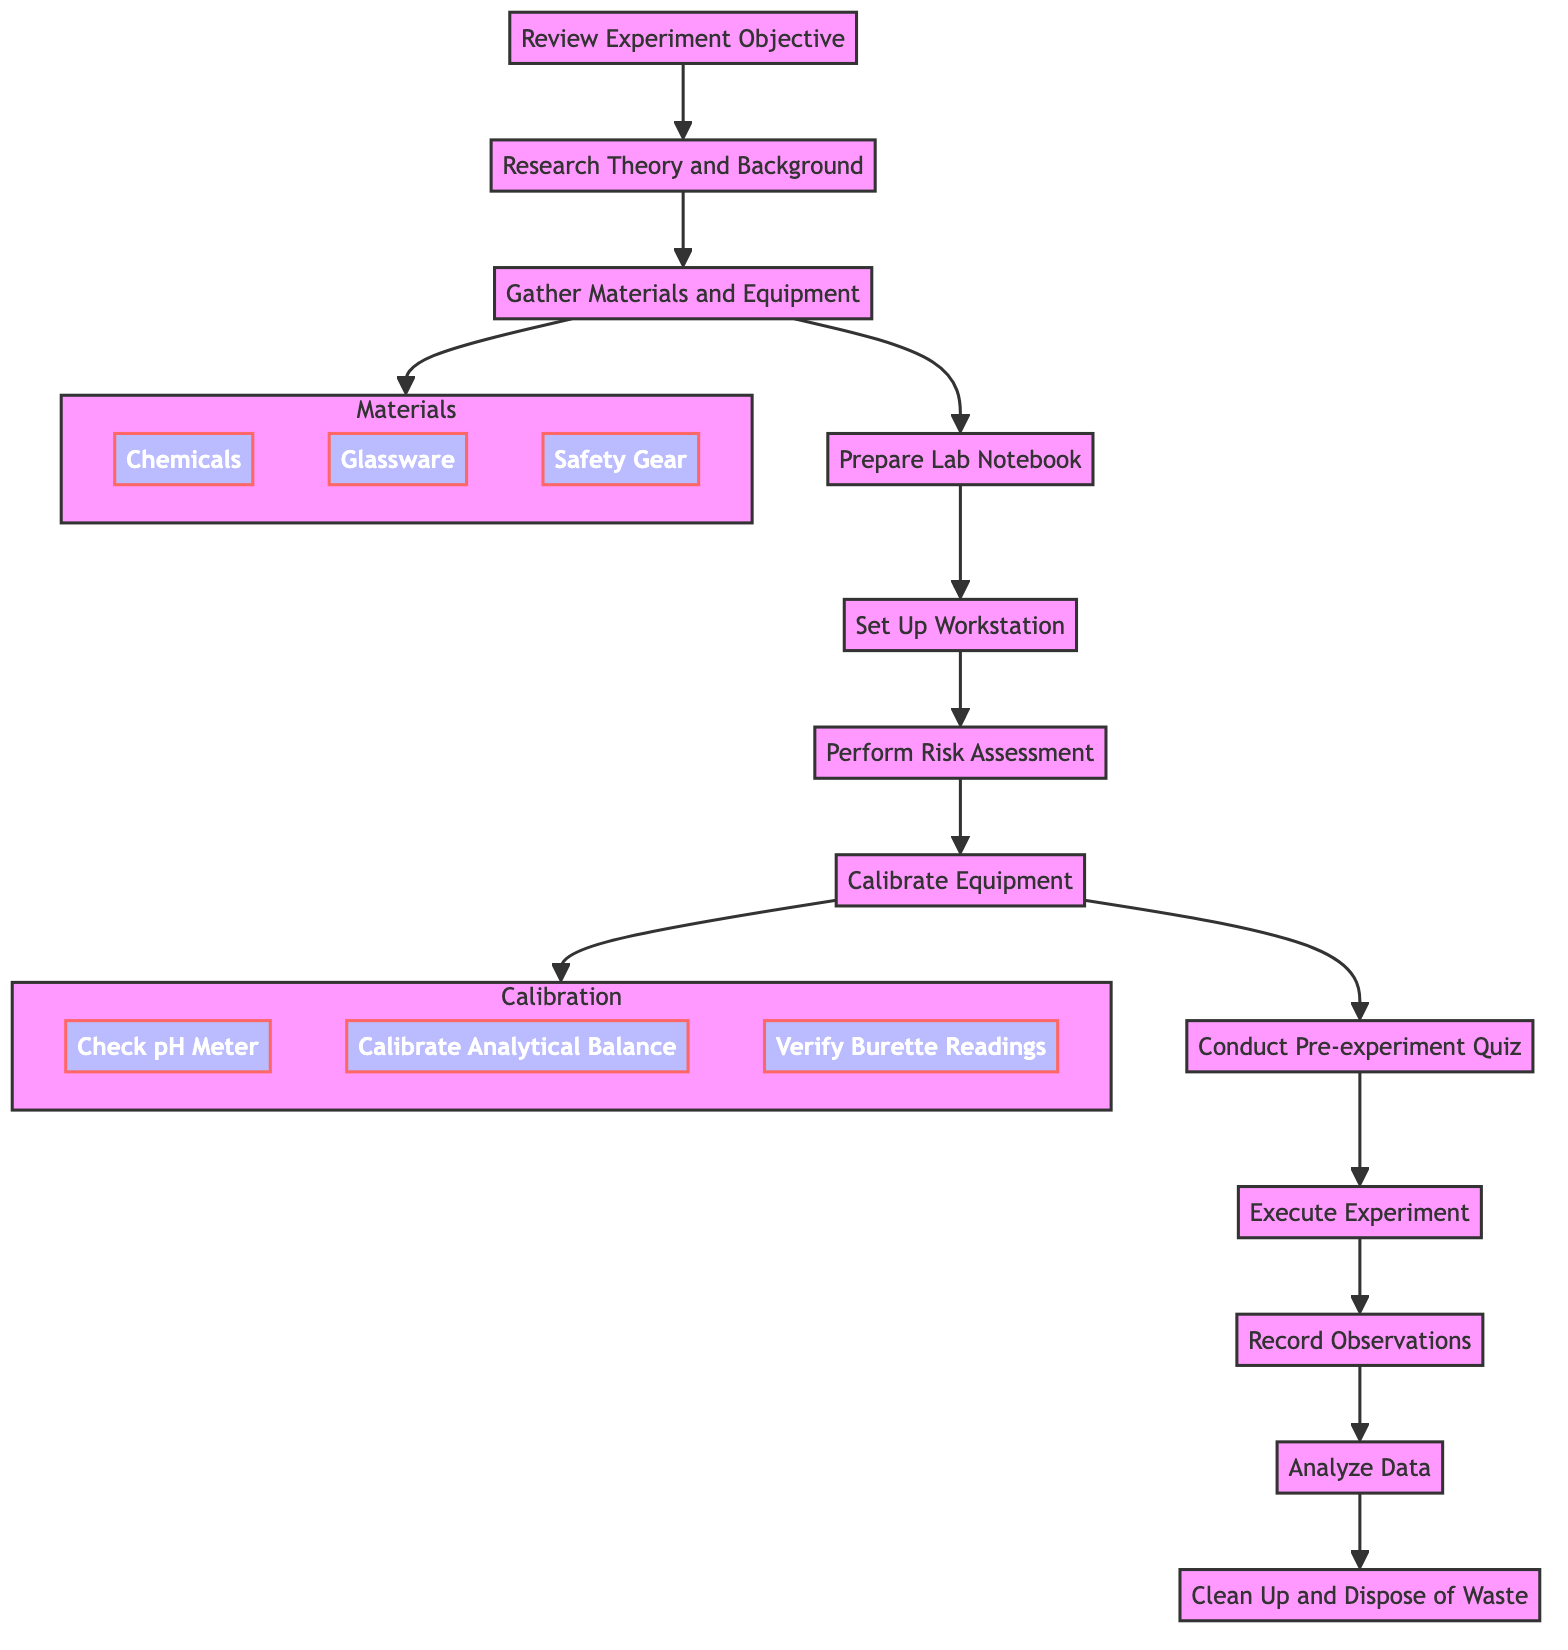What is the first step in preparing for a chemistry lab experiment? The first step is to "Review Experiment Objective," which indicates that understanding the purpose and goals of the experiment is essential before proceeding.
Answer: Review Experiment Objective How many main steps are in the flowchart? The flowchart consists of 12 main steps, beginning from "Review Experiment Objective" and ending with "Clean Up and Dispose of Waste." Each step represents a crucial part of preparing for the experiment.
Answer: 12 What materials are gathered in step three? In step three, "Gather Materials and Equipment," the materials specified include Chemicals (Hydrochloric acid, Sodium hydroxide), Glassware (Beakers, Flasks, Pipettes), and Safety Gear (Lab coat, Goggles, Gloves).
Answer: Chemicals, Glassware, Safety Gear Which step follows "Calibrate Equipment"? The step that follows "Calibrate Equipment" is "Conduct Pre-experiment Quiz." This means that after ensuring all equipment is calibrated, a quiz is conducted to verify understanding of the experiment's principles and safety protocols.
Answer: Conduct Pre-experiment Quiz What are the components in the "Calibration" subgraph? The "Calibration" subgraph includes three components: "Check pH Meter," "Calibrate Analytical Balance," and "Verify Burette Readings." These are all activities that help ensure the accuracy of the equipment used in the experiment.
Answer: Check pH Meter, Calibrate Analytical Balance, Verify Burette Readings How are the activities in the flowchart structured? The activities are structured in a linear sequence, where each step logically leads to the next—starting from the objectives and background research to executing the experiment and finally cleaning up after it. This sequence emphasizes the orderly preparation for a chemistry lab experiment.
Answer: Linear sequence Which two steps directly precede "Execute Experiment"? The two steps that directly precede "Execute Experiment" are "Conduct Pre-experiment Quiz" and "Calibrate Equipment." This indicates that a quiz on understanding and calibration needs to occur before executing the experiment.
Answer: Conduct Pre-experiment Quiz, Calibrate Equipment What is the last step in the preparation process? The last step in the preparation process is "Clean Up and Dispose of Waste." This step emphasizes the importance of properly cleaning and disposing of materials after the completion of the experiment to ensure safety and compliance with protocols.
Answer: Clean Up and Dispose of Waste 